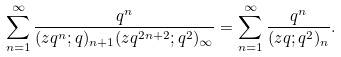Convert formula to latex. <formula><loc_0><loc_0><loc_500><loc_500>\sum _ { n = 1 } ^ { \infty } \frac { q ^ { n } } { ( z q ^ { n } ; q ) _ { n + 1 } ( z q ^ { 2 n + 2 } ; q ^ { 2 } ) _ { \infty } } = \sum _ { n = 1 } ^ { \infty } \frac { q ^ { n } } { ( z q ; q ^ { 2 } ) _ { n } } .</formula> 